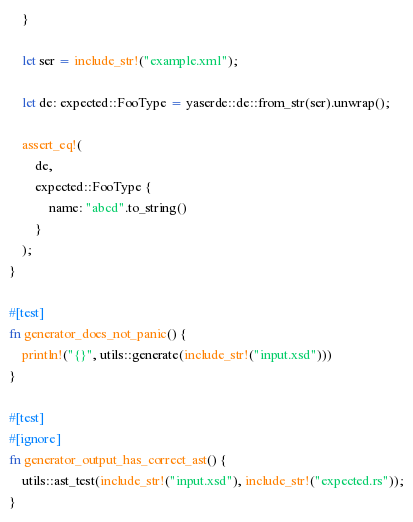<code> <loc_0><loc_0><loc_500><loc_500><_Rust_>    }

    let ser = include_str!("example.xml");

    let de: expected::FooType = yaserde::de::from_str(ser).unwrap();

    assert_eq!(
        de,
        expected::FooType {
            name: "abcd".to_string()
        }
    );
}

#[test]
fn generator_does_not_panic() {
    println!("{}", utils::generate(include_str!("input.xsd")))
}

#[test]
#[ignore]
fn generator_output_has_correct_ast() {
    utils::ast_test(include_str!("input.xsd"), include_str!("expected.rs"));
}
</code> 